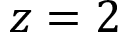<formula> <loc_0><loc_0><loc_500><loc_500>z = 2</formula> 